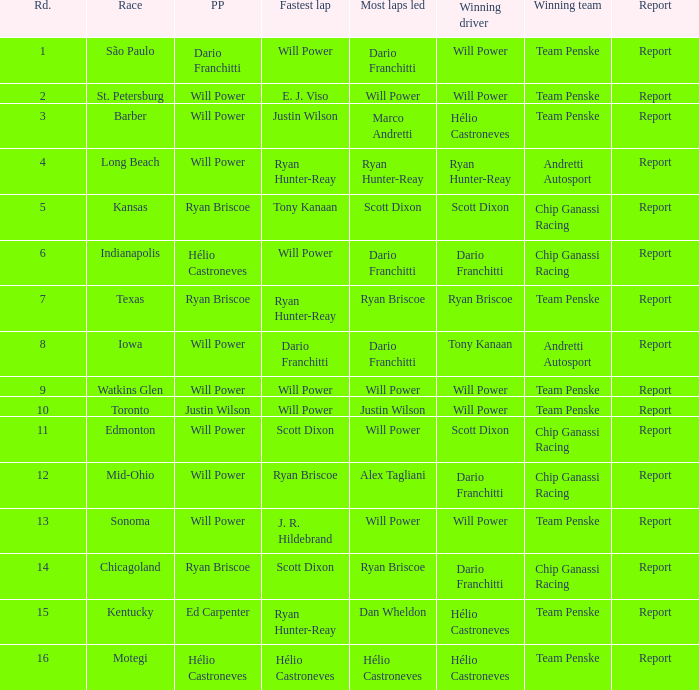What is the report for races where Will Power had both pole position and fastest lap? Report. 